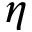Convert formula to latex. <formula><loc_0><loc_0><loc_500><loc_500>\eta</formula> 